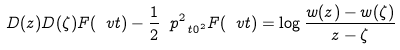Convert formula to latex. <formula><loc_0><loc_0><loc_500><loc_500>D ( z ) D ( \zeta ) F ( \ v t ) - \frac { 1 } { 2 } \ p ^ { 2 } _ { \ t 0 ^ { 2 } } F ( \ v t ) = \log \frac { w ( z ) - w ( \zeta ) } { z - \zeta }</formula> 